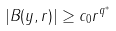Convert formula to latex. <formula><loc_0><loc_0><loc_500><loc_500>| B ( y , r ) | \geq c _ { 0 } r ^ { q ^ { * } }</formula> 